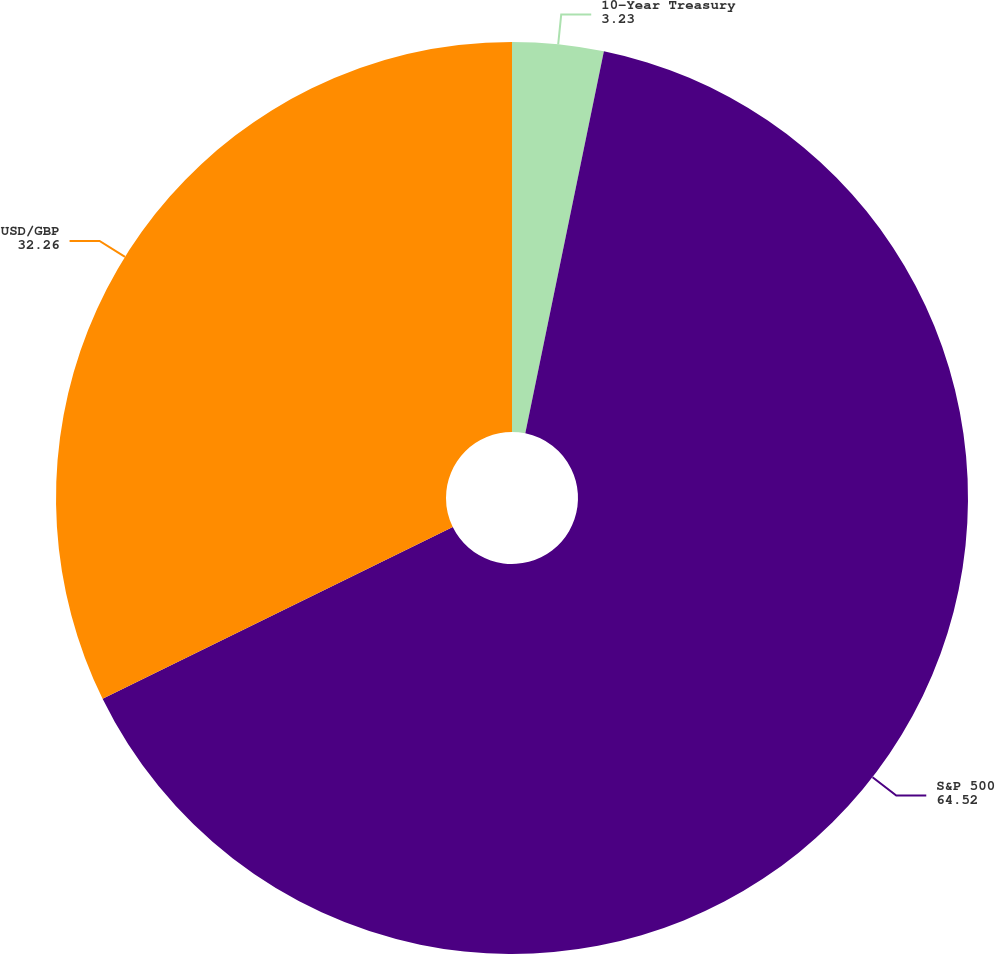<chart> <loc_0><loc_0><loc_500><loc_500><pie_chart><fcel>10-Year Treasury<fcel>S&P 500<fcel>USD/GBP<nl><fcel>3.23%<fcel>64.52%<fcel>32.26%<nl></chart> 